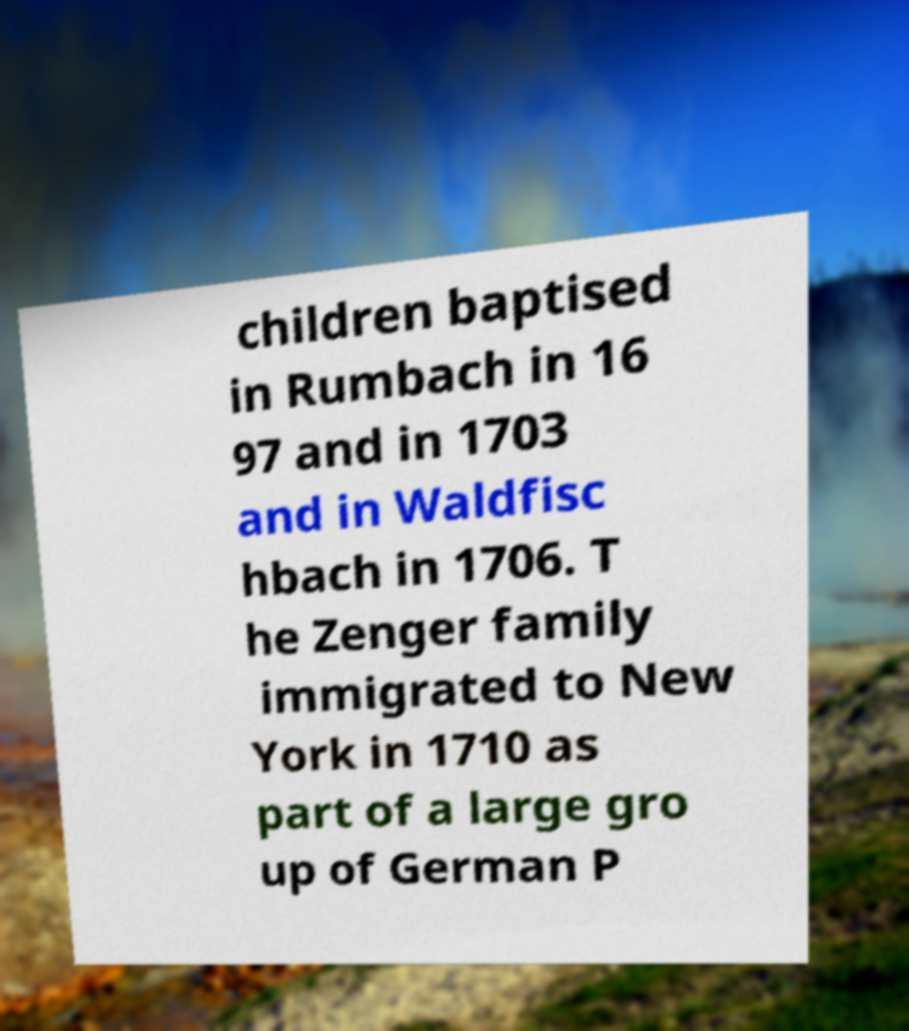For documentation purposes, I need the text within this image transcribed. Could you provide that? children baptised in Rumbach in 16 97 and in 1703 and in Waldfisc hbach in 1706. T he Zenger family immigrated to New York in 1710 as part of a large gro up of German P 